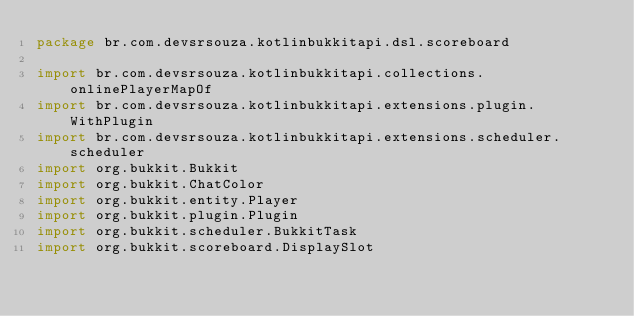Convert code to text. <code><loc_0><loc_0><loc_500><loc_500><_Kotlin_>package br.com.devsrsouza.kotlinbukkitapi.dsl.scoreboard

import br.com.devsrsouza.kotlinbukkitapi.collections.onlinePlayerMapOf
import br.com.devsrsouza.kotlinbukkitapi.extensions.plugin.WithPlugin
import br.com.devsrsouza.kotlinbukkitapi.extensions.scheduler.scheduler
import org.bukkit.Bukkit
import org.bukkit.ChatColor
import org.bukkit.entity.Player
import org.bukkit.plugin.Plugin
import org.bukkit.scheduler.BukkitTask
import org.bukkit.scoreboard.DisplaySlot</code> 